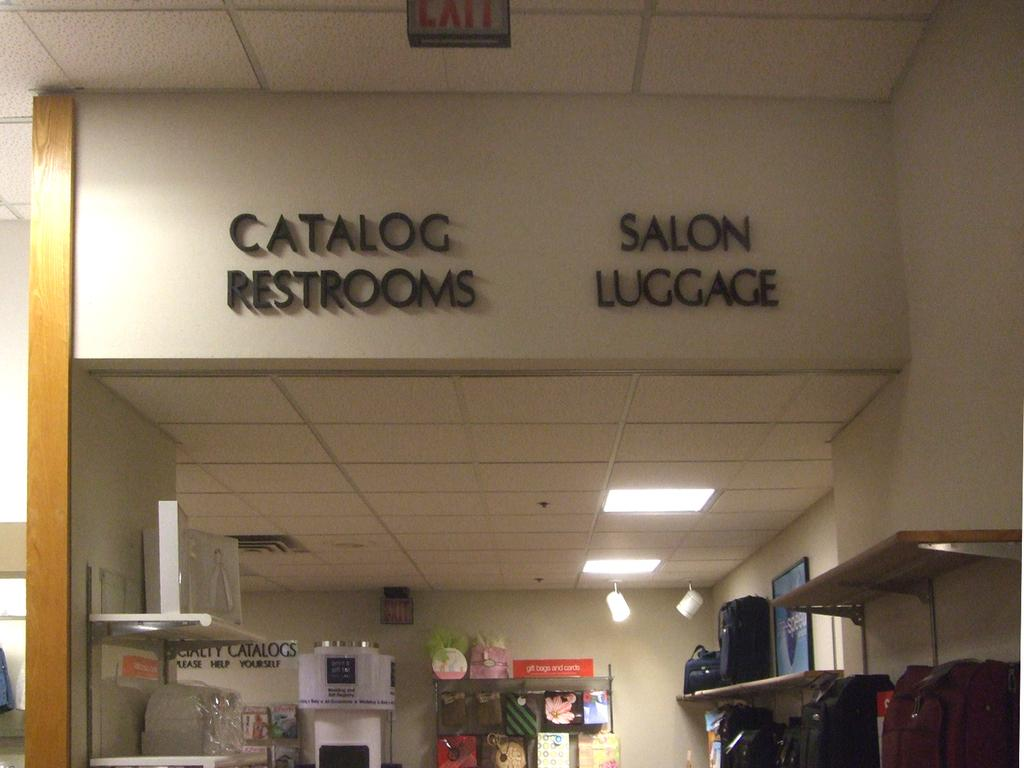<image>
Render a clear and concise summary of the photo. A hallway with signs for catalog restrooms and salon luggage 